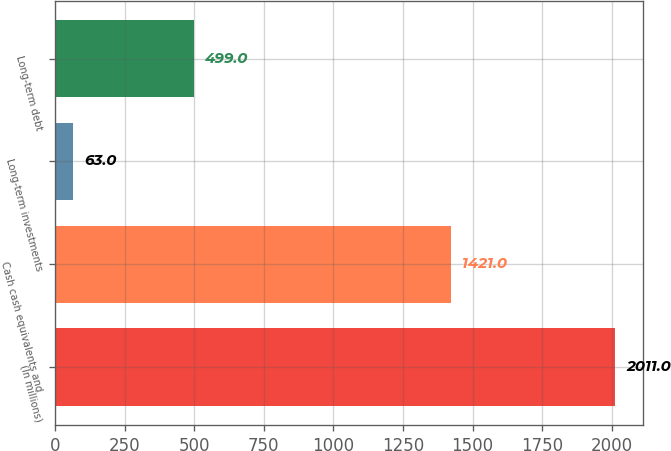Convert chart. <chart><loc_0><loc_0><loc_500><loc_500><bar_chart><fcel>(In millions)<fcel>Cash cash equivalents and<fcel>Long-term investments<fcel>Long-term debt<nl><fcel>2011<fcel>1421<fcel>63<fcel>499<nl></chart> 